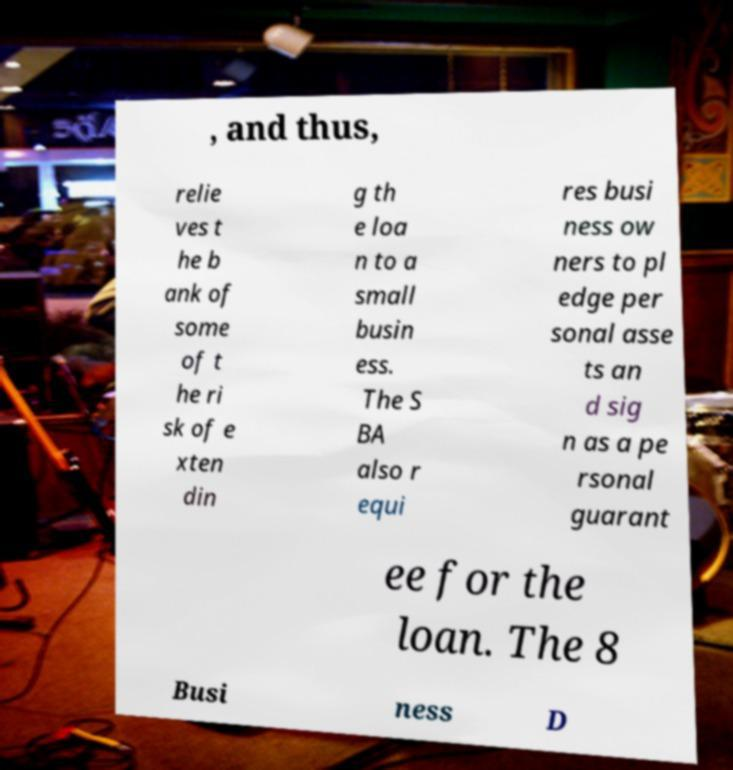Could you extract and type out the text from this image? , and thus, relie ves t he b ank of some of t he ri sk of e xten din g th e loa n to a small busin ess. The S BA also r equi res busi ness ow ners to pl edge per sonal asse ts an d sig n as a pe rsonal guarant ee for the loan. The 8 Busi ness D 